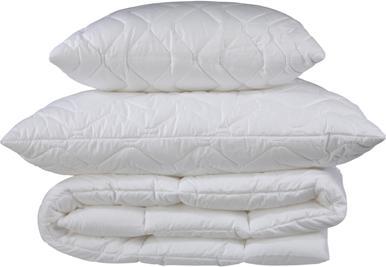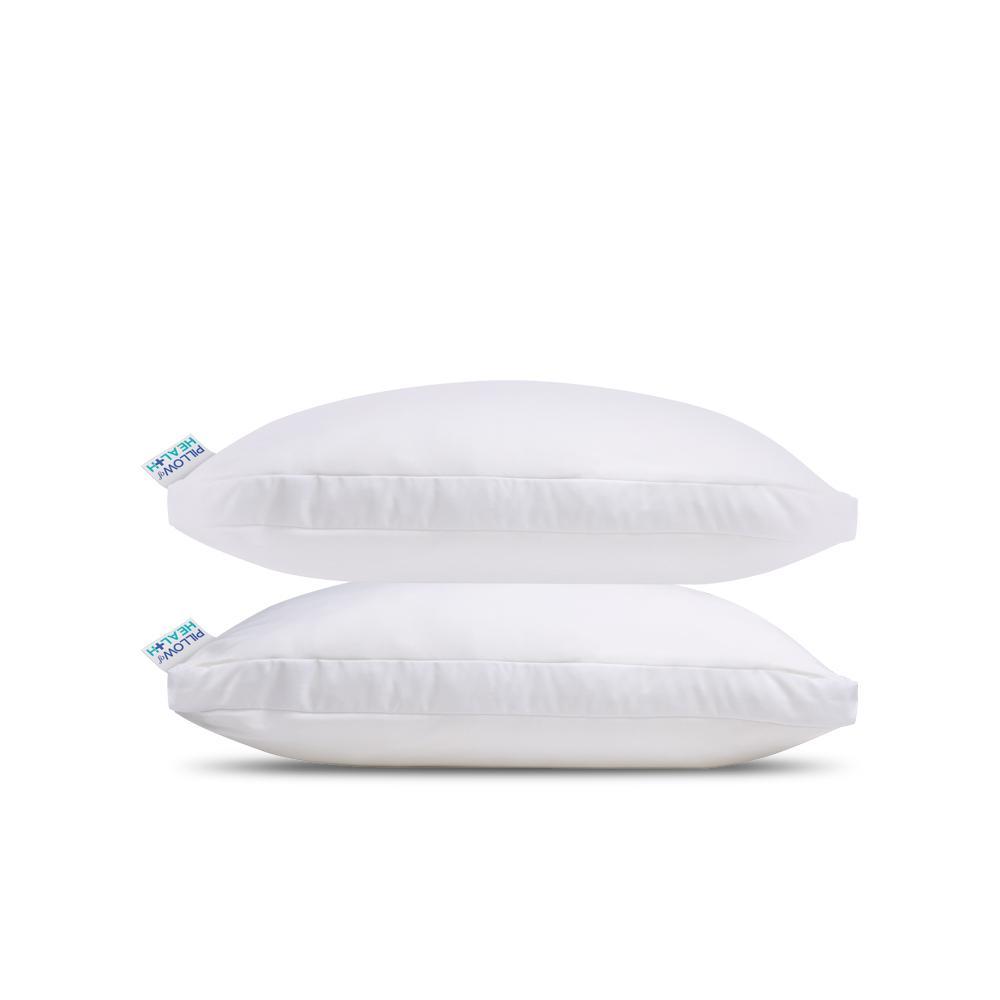The first image is the image on the left, the second image is the image on the right. Given the left and right images, does the statement "there are 4 pillows stacked on top of one another" hold true? Answer yes or no. No. The first image is the image on the left, the second image is the image on the right. For the images displayed, is the sentence "The right image contains a vertical stack of at least four pillows." factually correct? Answer yes or no. No. 